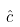<formula> <loc_0><loc_0><loc_500><loc_500>\hat { c }</formula> 